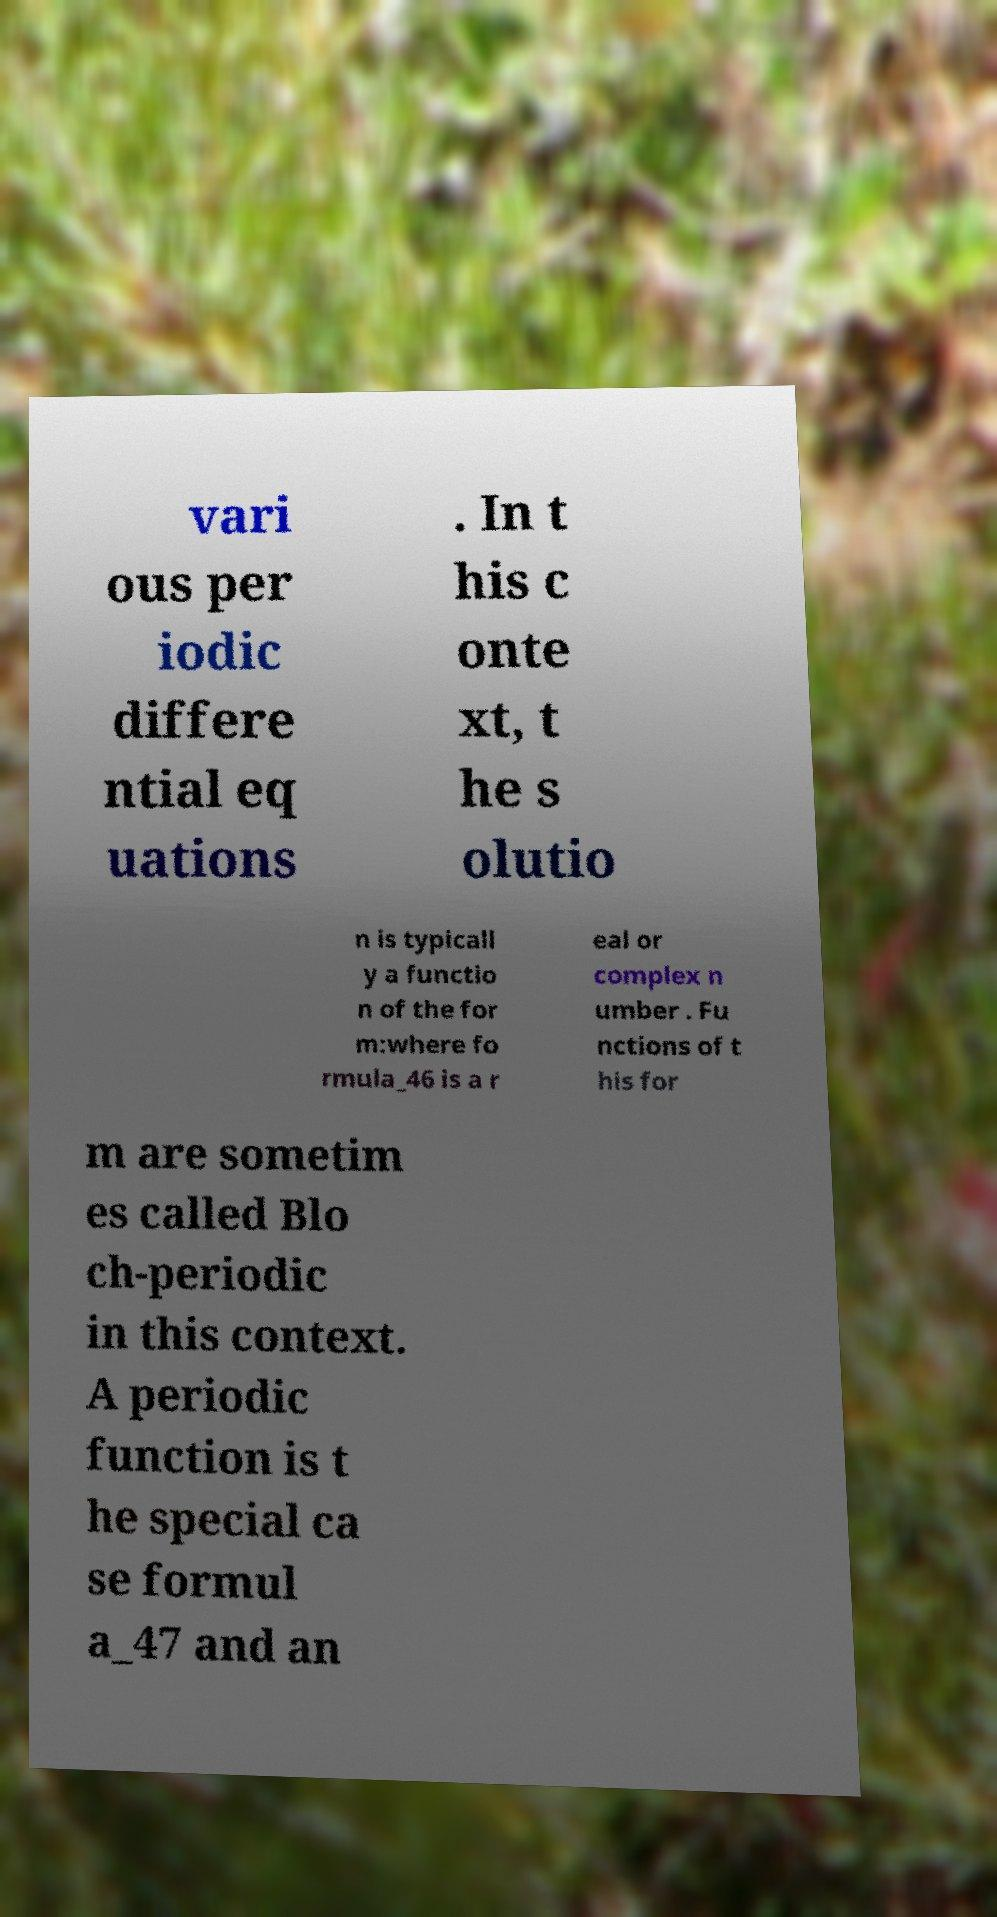Please read and relay the text visible in this image. What does it say? vari ous per iodic differe ntial eq uations . In t his c onte xt, t he s olutio n is typicall y a functio n of the for m:where fo rmula_46 is a r eal or complex n umber . Fu nctions of t his for m are sometim es called Blo ch-periodic in this context. A periodic function is t he special ca se formul a_47 and an 